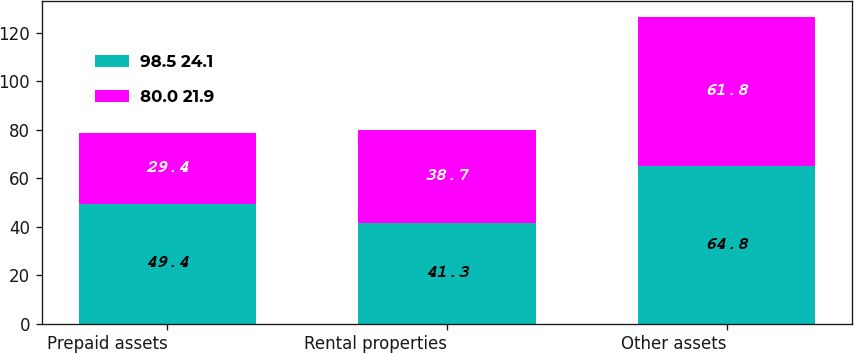<chart> <loc_0><loc_0><loc_500><loc_500><stacked_bar_chart><ecel><fcel>Prepaid assets<fcel>Rental properties<fcel>Other assets<nl><fcel>98.5 24.1<fcel>49.4<fcel>41.3<fcel>64.8<nl><fcel>80.0 21.9<fcel>29.4<fcel>38.7<fcel>61.8<nl></chart> 